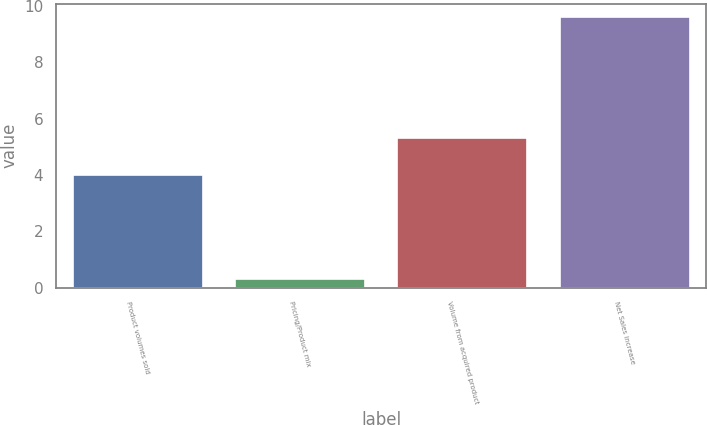<chart> <loc_0><loc_0><loc_500><loc_500><bar_chart><fcel>Product volumes sold<fcel>Pricing/Product mix<fcel>Volume from acquired product<fcel>Net Sales increase<nl><fcel>4<fcel>0.3<fcel>5.3<fcel>9.6<nl></chart> 